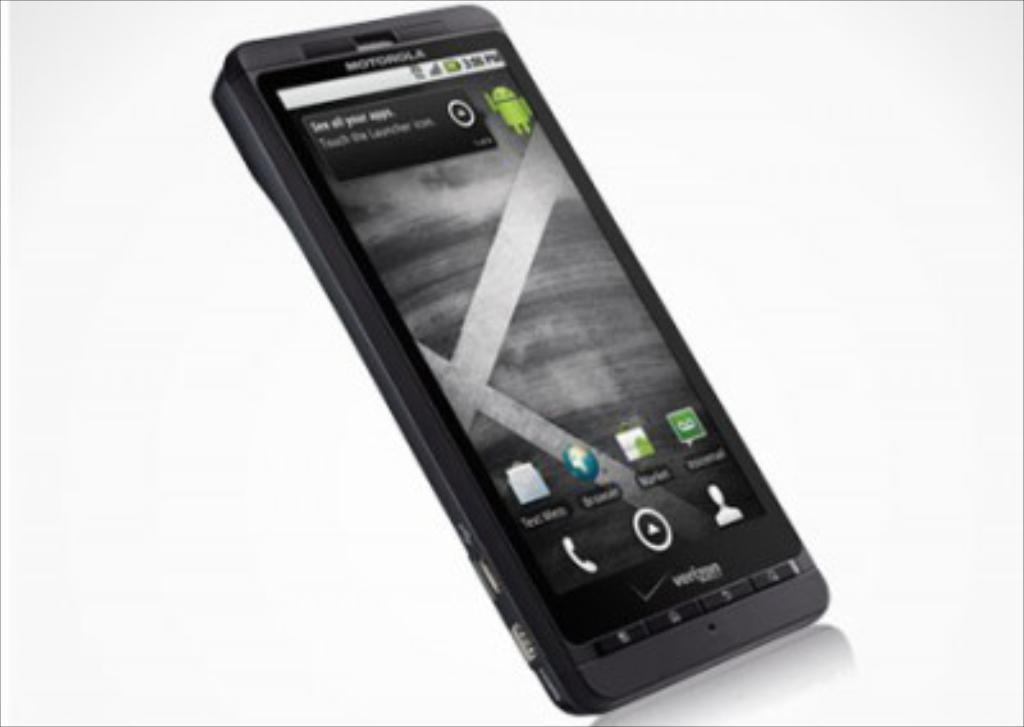What is the main subject in the middle of the picture? There is a mobile in the middle of the picture. What color is the background of the image? The background of the image is white. What type of iron can be seen in the image? There is no iron present in the image. What emotion is being displayed by the mobile in the image? The mobile is an inanimate object and does not display emotions like anger. 